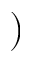<formula> <loc_0><loc_0><loc_500><loc_500>)</formula> 